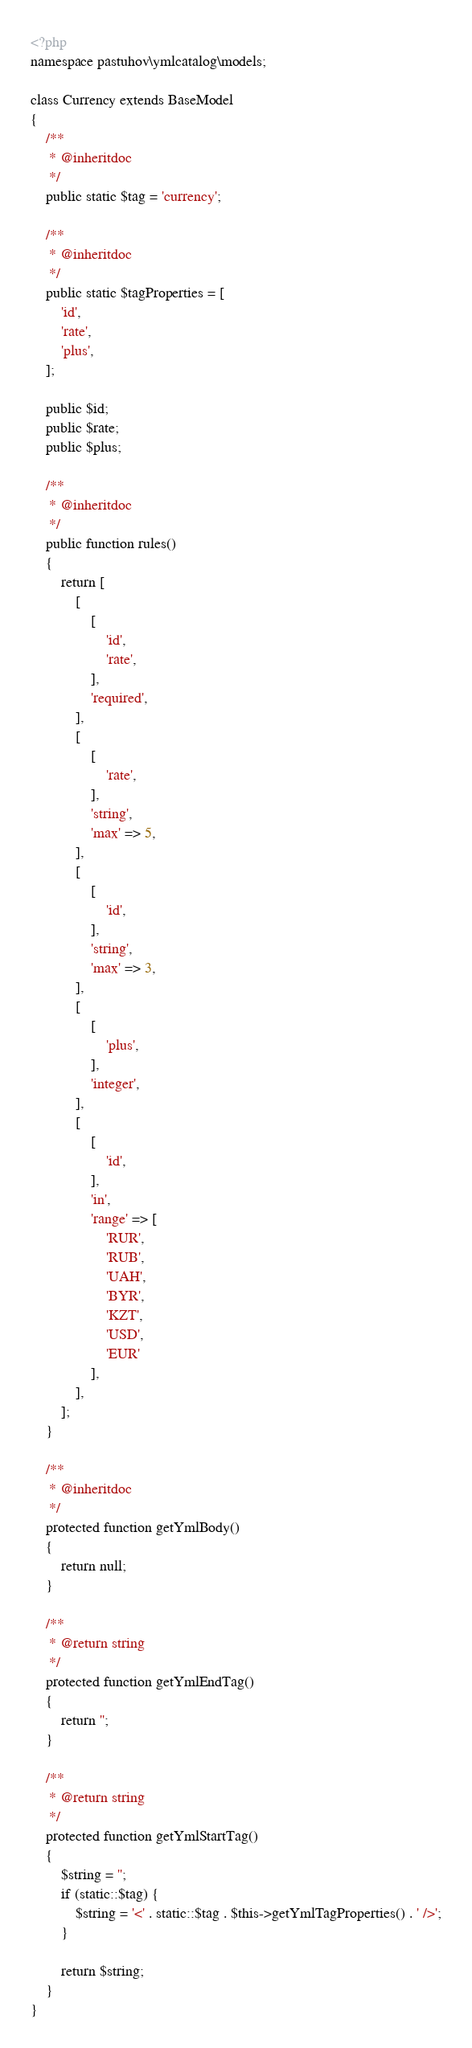Convert code to text. <code><loc_0><loc_0><loc_500><loc_500><_PHP_><?php
namespace pastuhov\ymlcatalog\models;

class Currency extends BaseModel
{
    /**
     * @inheritdoc
     */
    public static $tag = 'currency';

    /**
     * @inheritdoc
     */
    public static $tagProperties = [
        'id',
        'rate',
        'plus',
    ];

    public $id;
    public $rate;
    public $plus;

    /**
     * @inheritdoc
     */
    public function rules()
    {
        return [
            [
                [
                    'id',
                    'rate',
                ],
                'required',
            ],
            [
                [
                    'rate',
                ],
                'string',
                'max' => 5,
            ],
            [
                [
                    'id',
                ],
                'string',
                'max' => 3,
            ],
            [
                [
                    'plus',
                ],
                'integer',
            ],
            [
                [
                    'id',
                ],
                'in',
                'range' => [
                    'RUR',
                    'RUB',
                    'UAH',
                    'BYR',
                    'KZT',
                    'USD',
                    'EUR'
                ],
            ],
        ];
    }

    /**
     * @inheritdoc
     */
    protected function getYmlBody()
    {
        return null;
    }
    
    /**
     * @return string
     */
    protected function getYmlEndTag()
    {
        return '';
    }

    /**
     * @return string
     */
    protected function getYmlStartTag()
    {
        $string = '';
        if (static::$tag) {
            $string = '<' . static::$tag . $this->getYmlTagProperties() . ' />';
        }

        return $string;
    }
}
</code> 